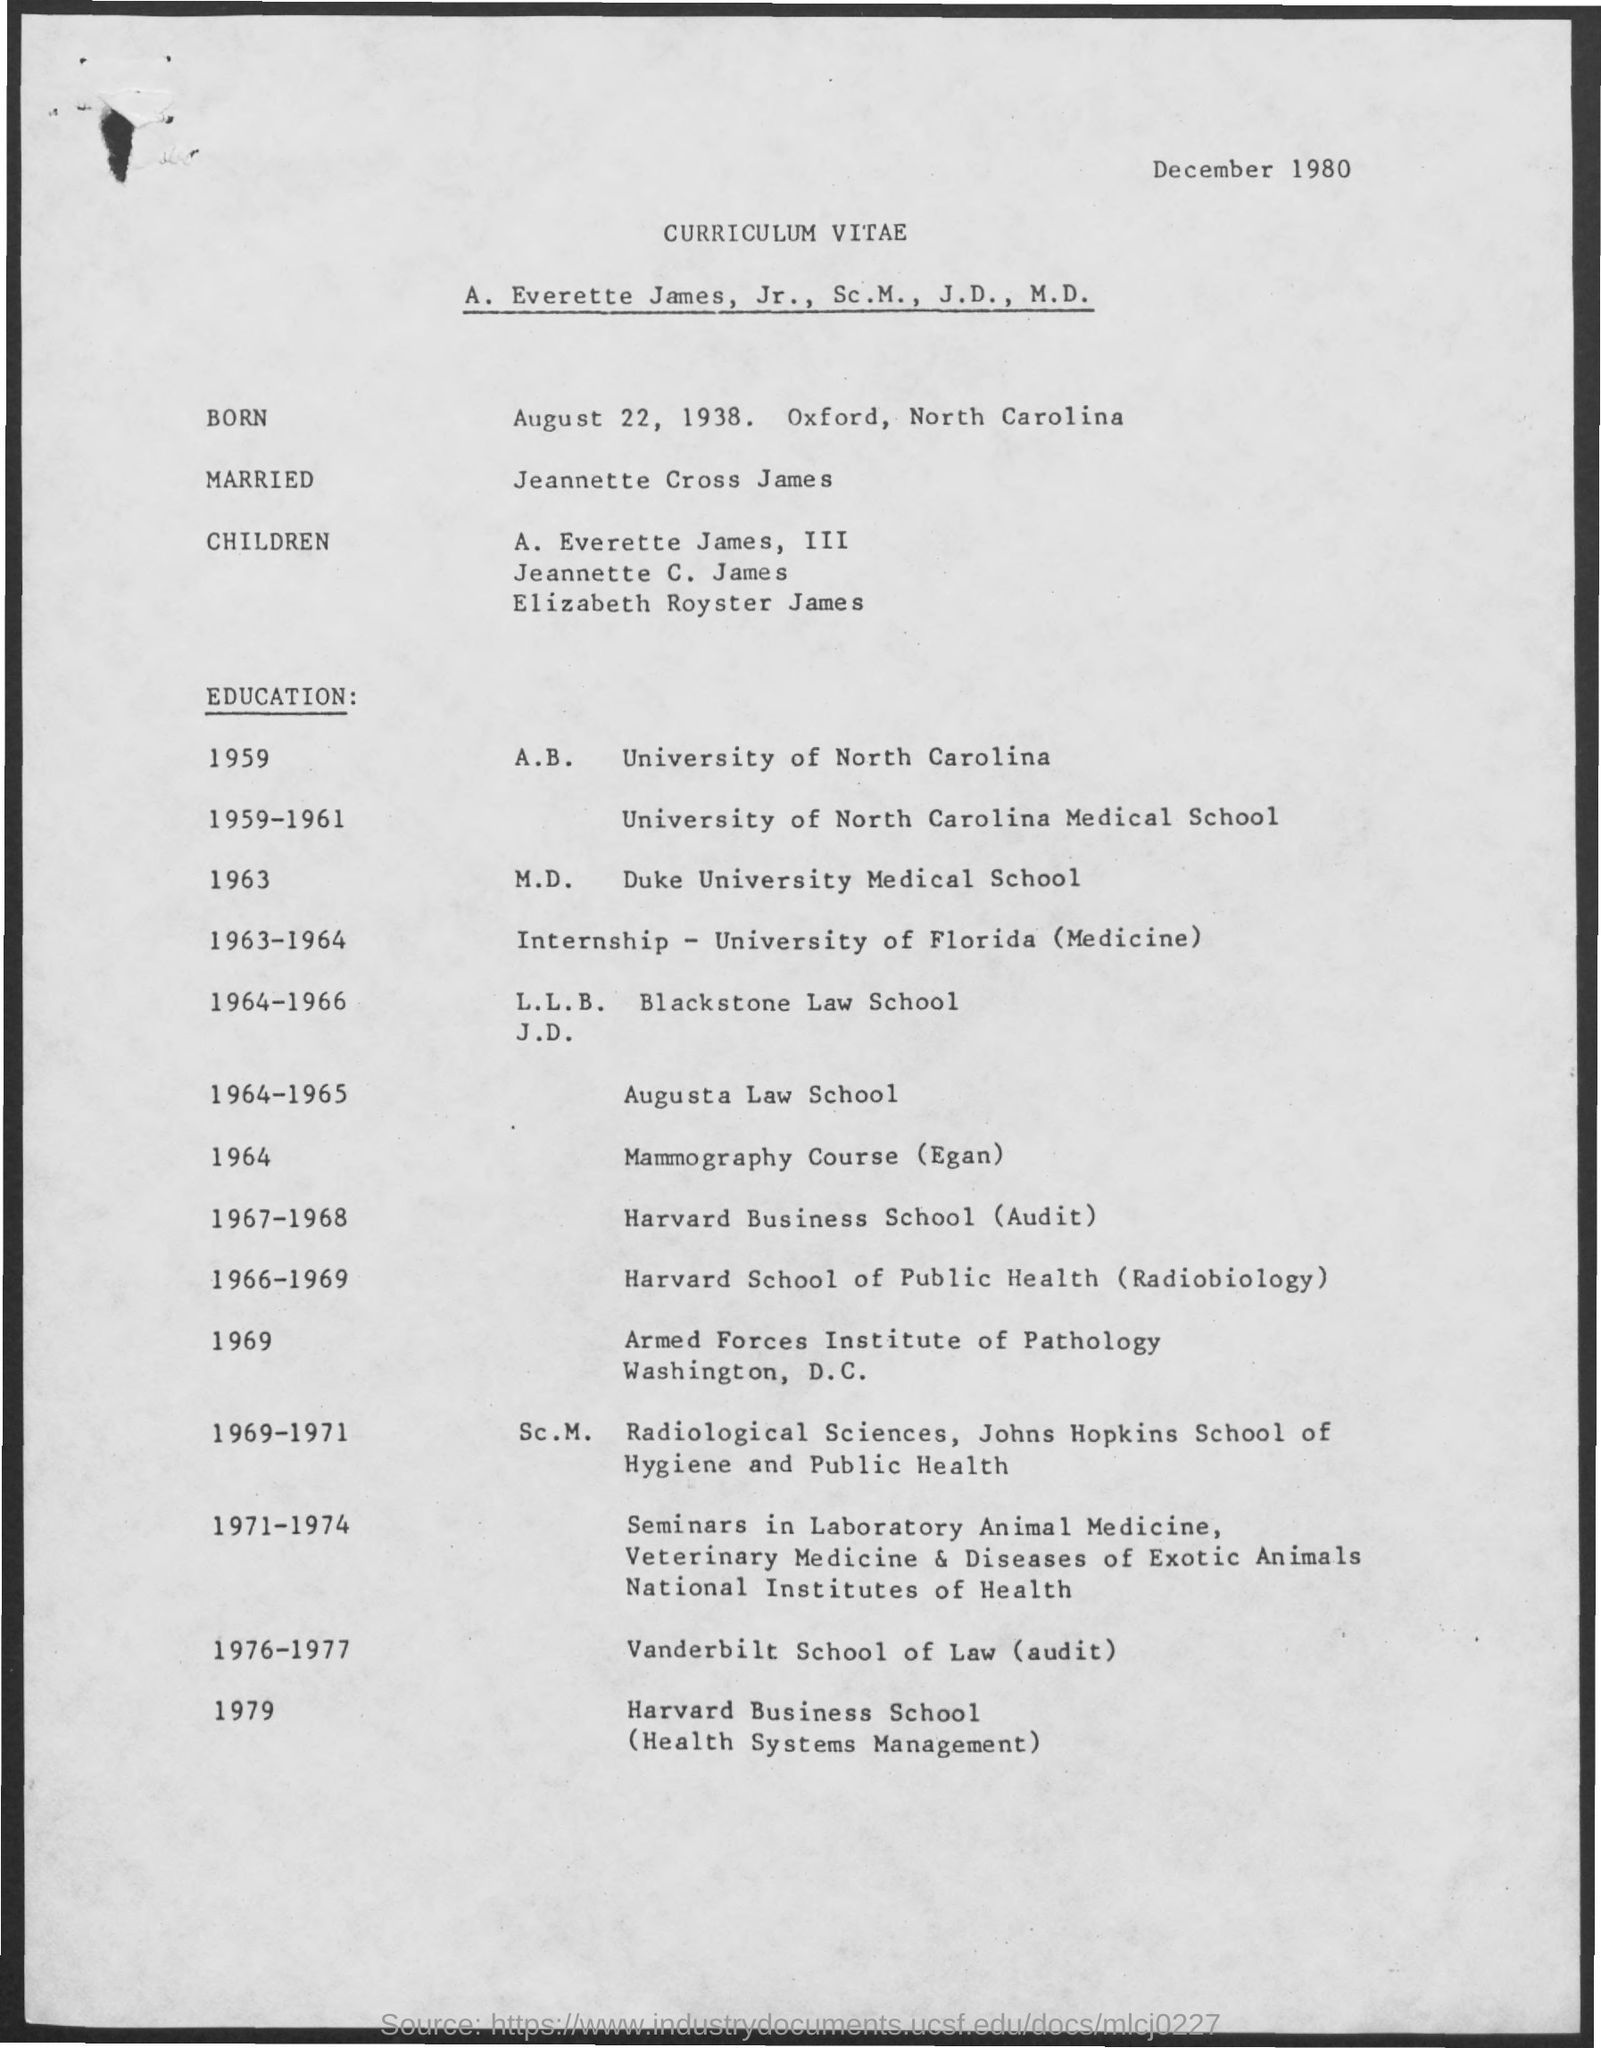Identify some key points in this picture. The document indicates that the date is December 1980. August 22, 1938 is the date of birth of the person in question. He attended Vanderbilt School of Law for an audit during the academic years 1976-1977. He attended Augusta Law School between 1964 and 1965. 